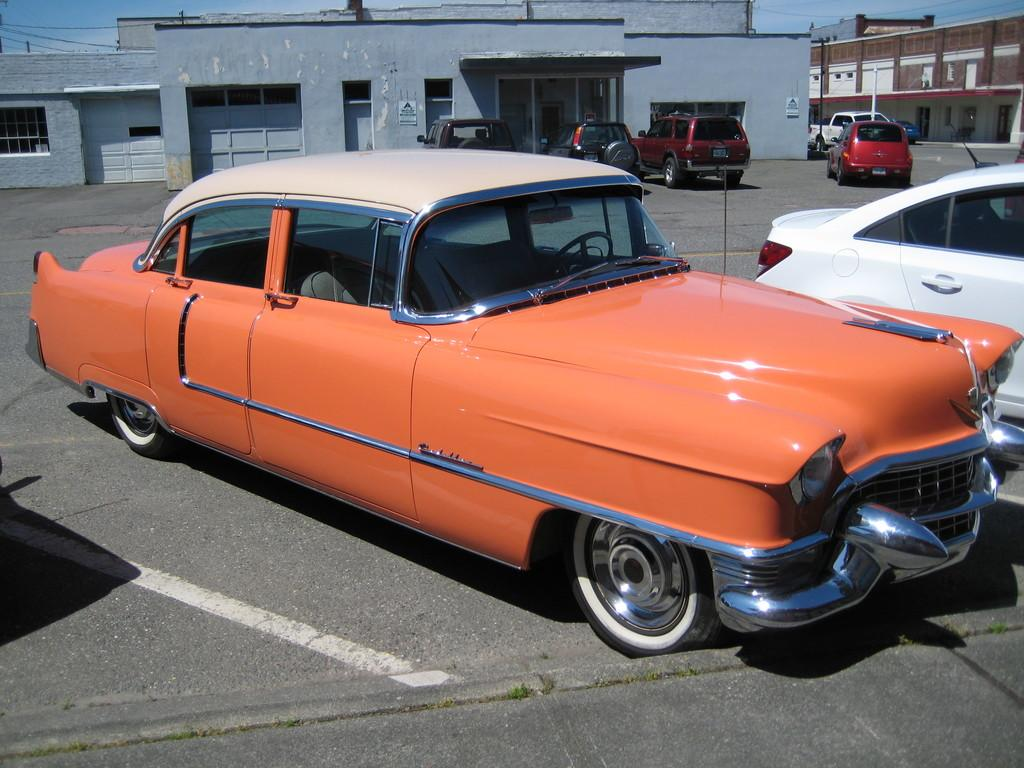What type of vehicles can be seen in the image? There are cars in the image. What structures are present in the image? There are buildings in the image. What architectural feature can be seen in the image? There are windows in the image. What vertical structures are present in the image? There are poles in the image. What part of the natural environment is visible in the image? The sky is visible in the image. What type of record can be seen spinning on a turntable in the image? There is no record or turntable present in the image. What type of art is displayed on the walls in the image? There is no art displayed on the walls in the image; the focus is on the cars, buildings, windows, poles, and sky. 